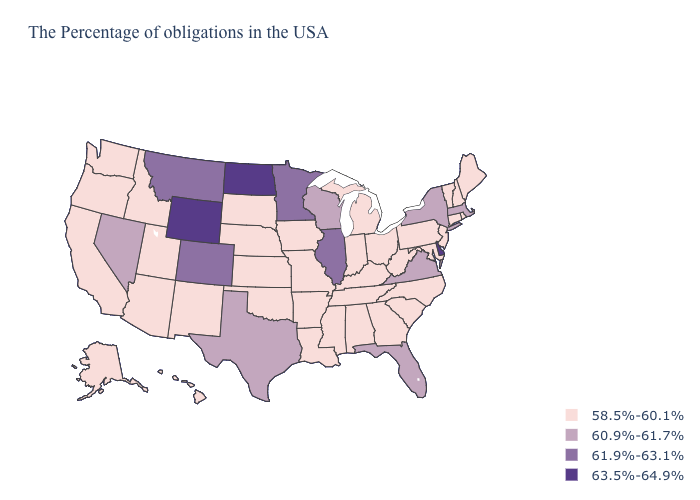Does North Dakota have the highest value in the USA?
Write a very short answer. Yes. What is the value of Pennsylvania?
Be succinct. 58.5%-60.1%. Name the states that have a value in the range 63.5%-64.9%?
Answer briefly. Delaware, North Dakota, Wyoming. Among the states that border Connecticut , which have the lowest value?
Short answer required. Rhode Island. What is the value of Maine?
Give a very brief answer. 58.5%-60.1%. Which states have the highest value in the USA?
Quick response, please. Delaware, North Dakota, Wyoming. Does New York have the lowest value in the USA?
Short answer required. No. Does the first symbol in the legend represent the smallest category?
Give a very brief answer. Yes. Name the states that have a value in the range 61.9%-63.1%?
Concise answer only. Illinois, Minnesota, Colorado, Montana. How many symbols are there in the legend?
Answer briefly. 4. Does Illinois have the lowest value in the MidWest?
Be succinct. No. How many symbols are there in the legend?
Answer briefly. 4. What is the value of Maryland?
Answer briefly. 58.5%-60.1%. What is the lowest value in the South?
Answer briefly. 58.5%-60.1%. Name the states that have a value in the range 63.5%-64.9%?
Short answer required. Delaware, North Dakota, Wyoming. 